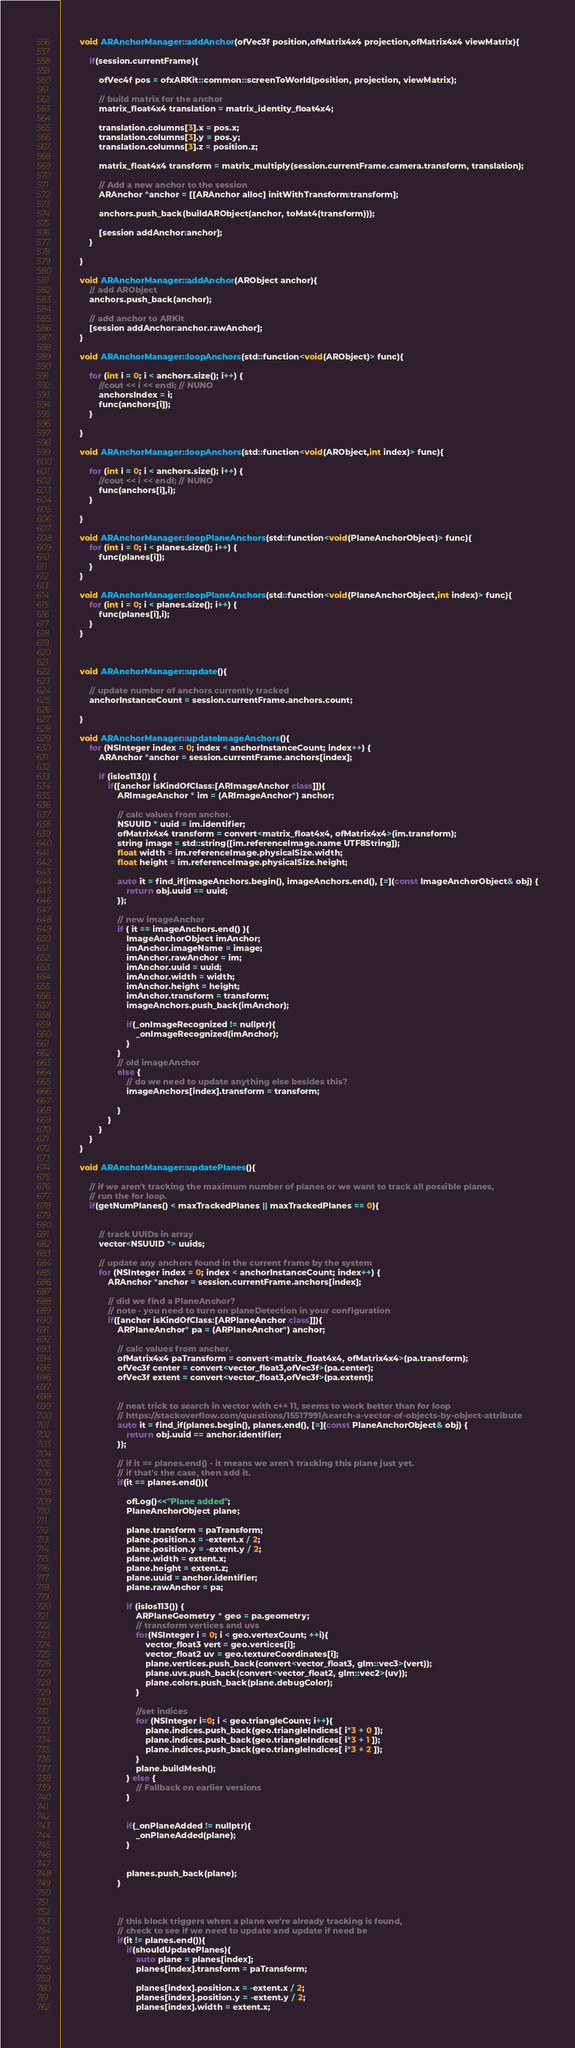<code> <loc_0><loc_0><loc_500><loc_500><_ObjectiveC_>        void ARAnchorManager::addAnchor(ofVec3f position,ofMatrix4x4 projection,ofMatrix4x4 viewMatrix){
            
            if(session.currentFrame){
                
                ofVec4f pos = ofxARKit::common::screenToWorld(position, projection, viewMatrix);
                
                // build matrix for the anchor
                matrix_float4x4 translation = matrix_identity_float4x4;
                
                translation.columns[3].x = pos.x;
                translation.columns[3].y = pos.y;
                translation.columns[3].z = position.z;
                
                matrix_float4x4 transform = matrix_multiply(session.currentFrame.camera.transform, translation);
                
                // Add a new anchor to the session
                ARAnchor *anchor = [[ARAnchor alloc] initWithTransform:transform];
                
                anchors.push_back(buildARObject(anchor, toMat4(transform)));
                
                [session addAnchor:anchor];
            }
            
        }
        
        void ARAnchorManager::addAnchor(ARObject anchor){
            // add ARObject
            anchors.push_back(anchor);
            
            // add anchor to ARKit
            [session addAnchor:anchor.rawAnchor];
        }
        
        void ARAnchorManager::loopAnchors(std::function<void(ARObject)> func){
            
            for (int i = 0; i < anchors.size(); i++) {
                //cout << i << endl; // NUNO
                anchorsIndex = i;
                func(anchors[i]);
            }
            
        }
        
        void ARAnchorManager::loopAnchors(std::function<void(ARObject,int index)> func){
            
            for (int i = 0; i < anchors.size(); i++) {
                //cout << i << endl; // NUNO
                func(anchors[i],i);
            }
            
        }
        
        void ARAnchorManager::loopPlaneAnchors(std::function<void(PlaneAnchorObject)> func){
            for (int i = 0; i < planes.size(); i++) {
                func(planes[i]);
            }
        }
        
        void ARAnchorManager::loopPlaneAnchors(std::function<void(PlaneAnchorObject,int index)> func){
            for (int i = 0; i < planes.size(); i++) {
                func(planes[i],i);
            }
        }
        
        
        
        void ARAnchorManager::update(){
            
            // update number of anchors currently tracked
            anchorInstanceCount = session.currentFrame.anchors.count;
            
        }
        
        void ARAnchorManager::updateImageAnchors(){
            for (NSInteger index = 0; index < anchorInstanceCount; index++) {
                ARAnchor *anchor = session.currentFrame.anchors[index];
                
                if (isIos113()) {
                    if([anchor isKindOfClass:[ARImageAnchor class]]){
                        ARImageAnchor * im = (ARImageAnchor*) anchor;
                        
                        // calc values from anchor.
                        NSUUID * uuid = im.identifier;
                        ofMatrix4x4 transform = convert<matrix_float4x4, ofMatrix4x4>(im.transform);
                        string image = std::string([im.referenceImage.name UTF8String]);
                        float width = im.referenceImage.physicalSize.width;
                        float height = im.referenceImage.physicalSize.height;
                        
                        auto it = find_if(imageAnchors.begin(), imageAnchors.end(), [=](const ImageAnchorObject& obj) {
                            return obj.uuid == uuid;
                        });
                        
                        // new imageAnchor
                        if ( it == imageAnchors.end() ){
                            ImageAnchorObject imAnchor;
                            imAnchor.imageName = image;
                            imAnchor.rawAnchor = im;
                            imAnchor.uuid = uuid;
                            imAnchor.width = width;
                            imAnchor.height = height;
                            imAnchor.transform = transform;
                            imageAnchors.push_back(imAnchor);
                            
                            if(_onImageRecognized != nullptr){
                                _onImageRecognized(imAnchor);
                            }
                        }
                        // old imageAnchor
                        else {
                            // do we need to update anything else besides this?
                            imageAnchors[index].transform = transform;
                            
                        }
                    }
                }
            }
        }
        
        void ARAnchorManager::updatePlanes(){
            
            // if we aren't tracking the maximum number of planes or we want to track all possible planes,
            // run the for loop.
            if(getNumPlanes() < maxTrackedPlanes || maxTrackedPlanes == 0){
                
                
                // track UUIDs in array
                vector<NSUUID *> uuids;
                
                // update any anchors found in the current frame by the system
                for (NSInteger index = 0; index < anchorInstanceCount; index++) {
                    ARAnchor *anchor = session.currentFrame.anchors[index];
                    
                    // did we find a PlaneAnchor?
                    // note - you need to turn on planeDetection in your configuration
                    if([anchor isKindOfClass:[ARPlaneAnchor class]]){
                        ARPlaneAnchor* pa = (ARPlaneAnchor*) anchor;
                        
                        // calc values from anchor.
                        ofMatrix4x4 paTransform = convert<matrix_float4x4, ofMatrix4x4>(pa.transform);
                        ofVec3f center = convert<vector_float3,ofVec3f>(pa.center);
                        ofVec3f extent = convert<vector_float3,ofVec3f>(pa.extent);
                        
                        
                        // neat trick to search in vector with c++ 11, seems to work better than for loop
                        // https://stackoverflow.com/questions/15517991/search-a-vector-of-objects-by-object-attribute
                        auto it = find_if(planes.begin(), planes.end(), [=](const PlaneAnchorObject& obj) {
                            return obj.uuid == anchor.identifier;
                        });
                        
                        // if it == planes.end() - it means we aren't tracking this plane just yet.
                        // if that's the case, then add it.
                        if(it == planes.end()){
                            
                            ofLog()<<"Plane added";
                            PlaneAnchorObject plane;
                            
                            plane.transform = paTransform;
                            plane.position.x = -extent.x / 2;
                            plane.position.y = -extent.y / 2;
                            plane.width = extent.x;
                            plane.height = extent.z;
                            plane.uuid = anchor.identifier;
                            plane.rawAnchor = pa;
                            
                            if (isIos113()) {
                                ARPlaneGeometry * geo = pa.geometry;
                                // transform vertices and uvs
                                for(NSInteger i = 0; i < geo.vertexCount; ++i){
                                    vector_float3 vert = geo.vertices[i];
                                    vector_float2 uv = geo.textureCoordinates[i];
                                    plane.vertices.push_back(convert<vector_float3, glm::vec3>(vert));
                                    plane.uvs.push_back(convert<vector_float2, glm::vec2>(uv));
                                    plane.colors.push_back(plane.debugColor);
                                }
                                
                                //set indices
                                for (NSInteger i=0; i < geo.triangleCount; i++){
                                    plane.indices.push_back(geo.triangleIndices[ i*3 + 0 ]);
                                    plane.indices.push_back(geo.triangleIndices[ i*3 + 1 ]);
                                    plane.indices.push_back(geo.triangleIndices[ i*3 + 2 ]);
                                }
                                plane.buildMesh();
                            } else {
                                // Fallback on earlier versions
                            }
                            
                            
                            if(_onPlaneAdded != nullptr){
                                _onPlaneAdded(plane);
                            }
                            
                            
                            planes.push_back(plane);
                        }
                        
                        
                        
                        // this block triggers when a plane we're already tracking is found,
                        // check to see if we need to update and update if need be
                        if(it != planes.end()){
                            if(shouldUpdatePlanes){
                                auto plane = planes[index];
                                planes[index].transform = paTransform;
                                
                                planes[index].position.x = -extent.x / 2;
                                planes[index].position.y = -extent.y / 2;
                                planes[index].width = extent.x;</code> 